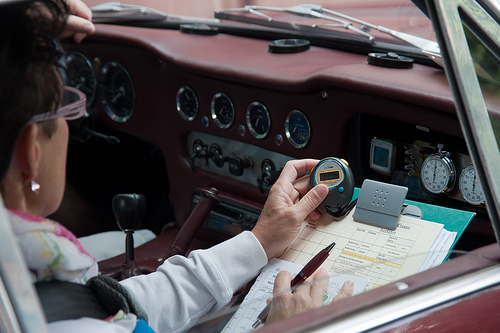What are the details of the car's interior design visible in the image? The car's interior features a rich, burgundy leather dashboard, wooden panel inclusions, and an array of both modern and classic instruments that suggest meticulous maintenance and an appreciation for vintage aesthetics. What do the instruments on the dashboard indicate about the car's features? The instruments, including various gauges and a prominent tachometer, denote a car designed for performance and precision, typical of luxury sports cars from the mid-20th century. 